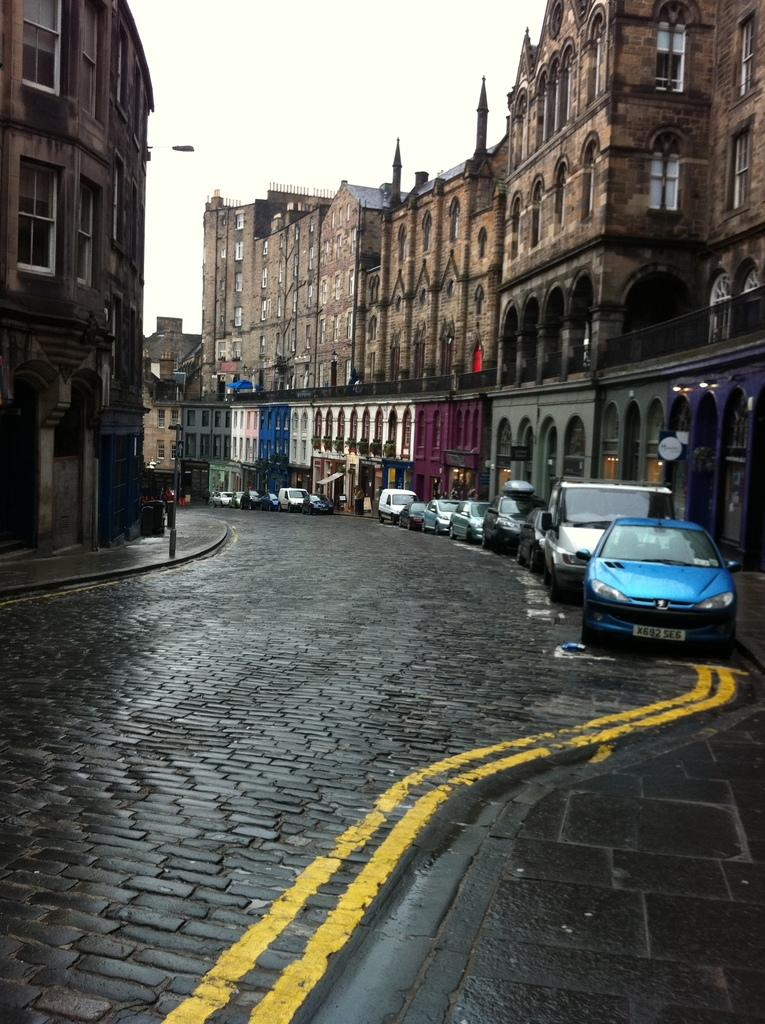<image>
Describe the image concisely. A winding street has cars parked online the side and one of them has a plate that says X692 SE6. 